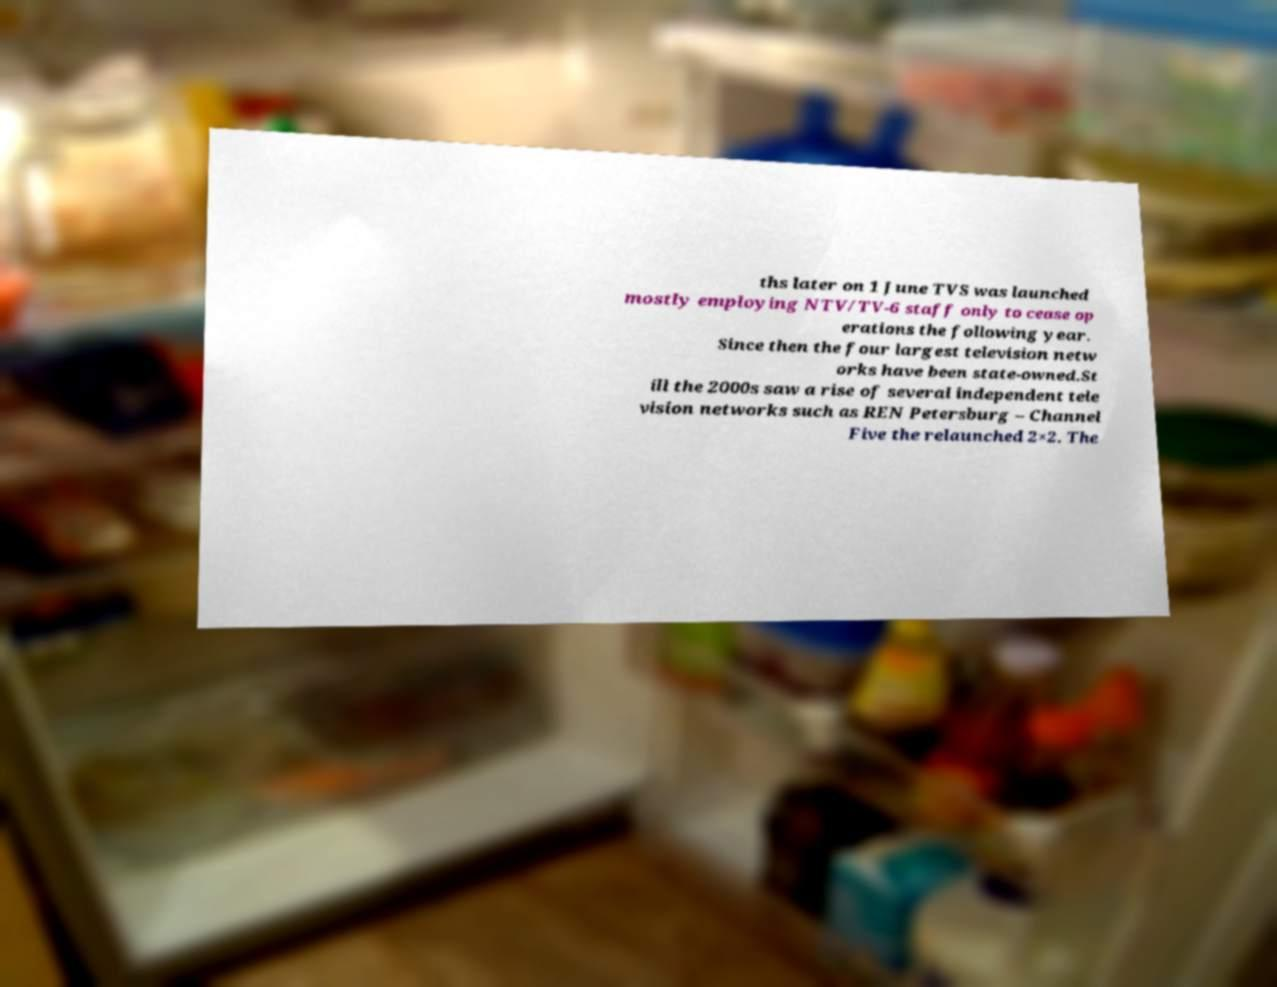Please identify and transcribe the text found in this image. ths later on 1 June TVS was launched mostly employing NTV/TV-6 staff only to cease op erations the following year. Since then the four largest television netw orks have been state-owned.St ill the 2000s saw a rise of several independent tele vision networks such as REN Petersburg – Channel Five the relaunched 2×2. The 